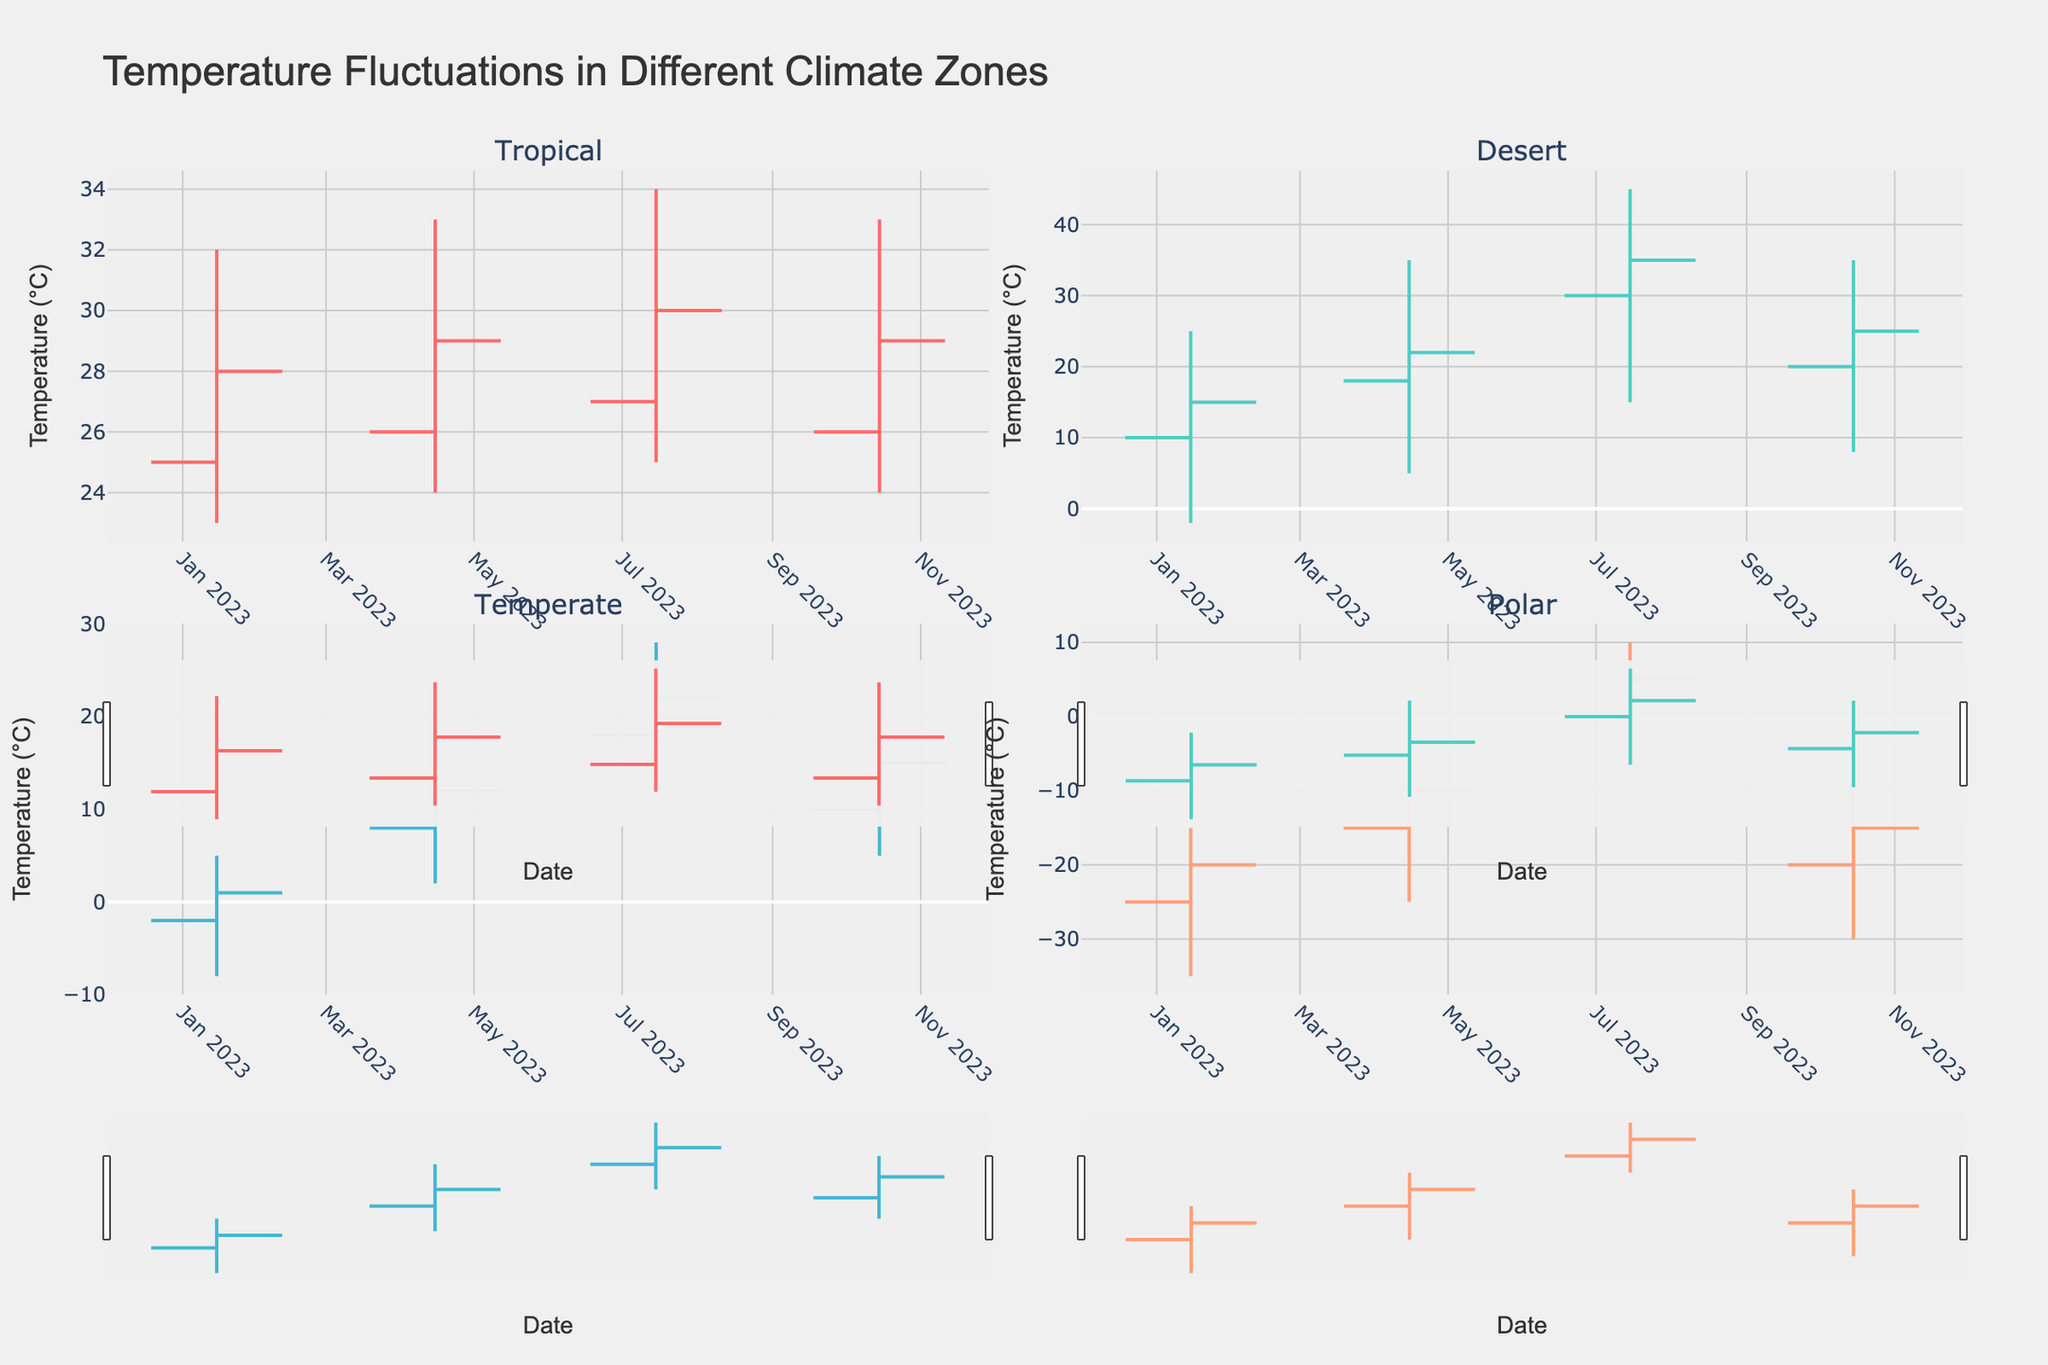What is the title of the chart? The title of the chart is usually located at the top. In this case, the title is "Temperature Fluctuations in Different Climate Zones".
Answer: Temperature Fluctuations in Different Climate Zones How many climate zones are represented in the figure? Count the number of subplot titles. There are subplots for Tropical, Desert, Temperate, and Polar zones.
Answer: Four In the Tropical zone, what is the highest temperature recorded and in which month? Locate the Tropical zone subplot and identify the highest point on the high line. The highest temperature of 34°C is recorded in July.
Answer: 34°C in July Which zone has the greatest temperature range in January? Compare the high and low values for each zone in January. The Desert zone has the highest range from 25°C to -2°C, a total range of 27°C.
Answer: Desert Compare the closing temperatures in the Temperate zone for January and April. Which month had a higher closing temperature? Look at the closing values in the Temperate zone for both months. The closing temperature is 1°C in January and 12°C in April. April is higher.
Answer: April What is the opening temperature in the Polar zone in April? Check the opening value in the Polar zone subplot for April. The opening temperature is -15°C.
Answer: -15°C In which month did the Tropical zone experience a decrease in the closing temperature compared to its opening temperature? Compare the opening and closing values for each month. In April and October, the closing temperature is higher than the opening; in January and July, it is also higher. Thus, it never experienced a decrease.
Answer: None Which zone shows the highest closing temperature in July? Compare the closing temperatures for all zones in July. The Desert zone shows the highest closing temperature at 35°C.
Answer: Desert For the Polar zone, in which month does the low temperature reach its lowest point? Check the low values in the Polar zone subplot. The lowest point, -35°C, is reached in January.
Answer: January Which climate zone has the smallest difference between the highest and lowest temperatures in October? Calculate the range (high-low) for each zone in October. The Temperate zone has the smallest range: 20°C - 5°C = 15°C.
Answer: Temperate 